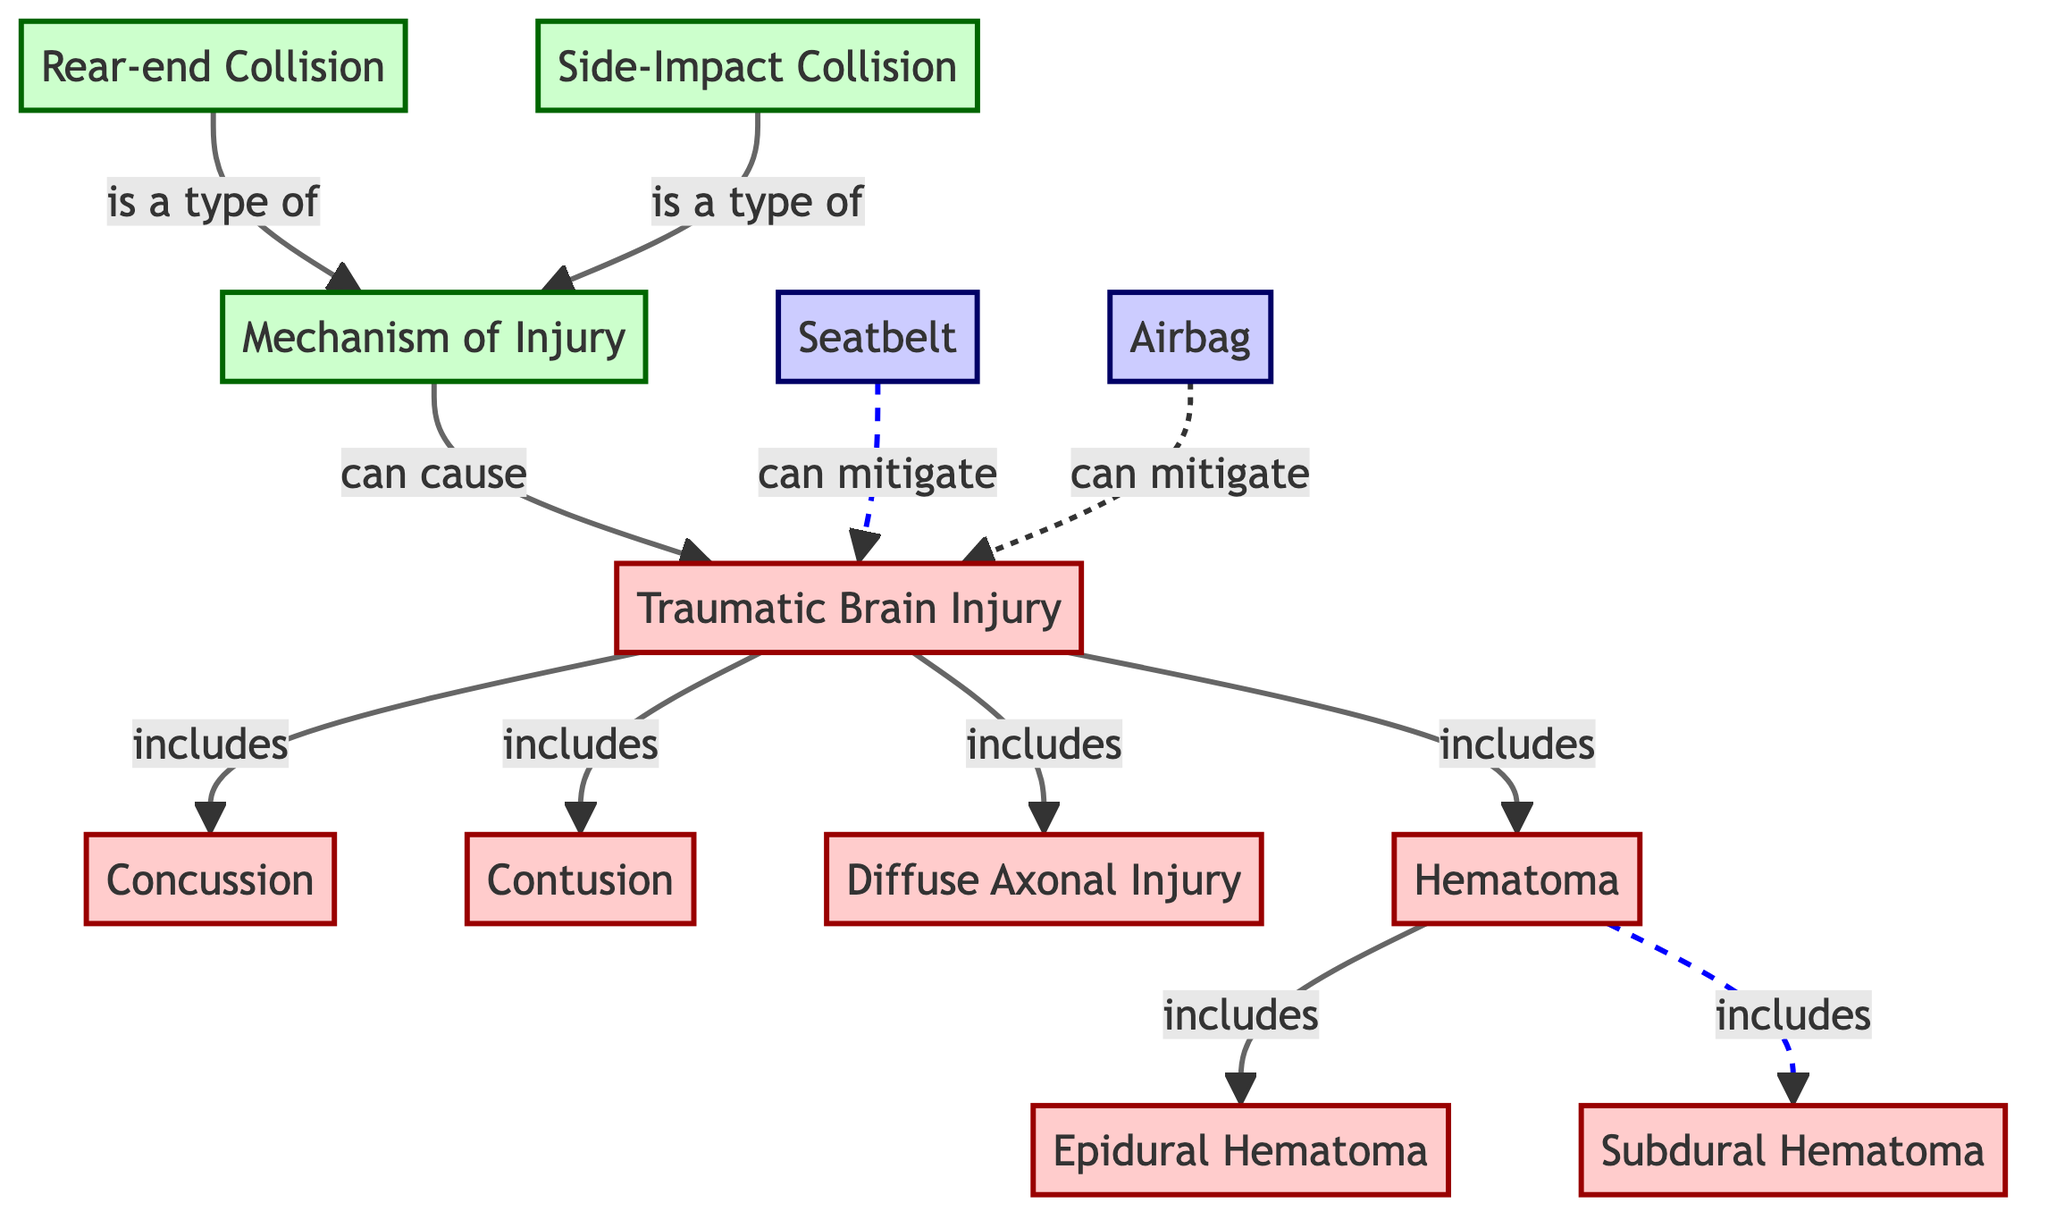What are the types of injuries included under Traumatic Brain Injury? The diagram indicates that Traumatic Brain Injury includes Concussion, Contusion, Diffuse Axonal Injury, and Hematoma. By following the connection from the TBI node, we can identify these injury types listed.
Answer: Concussion, Contusion, Diffuse Axonal Injury, Hematoma How many types of hematoma are specified in the diagram? The diagram shows that there are two types of hematoma: Epidural Hematoma and Subdural Hematoma. By tracing the connection from the Hematoma node, we see it branches into these two types.
Answer: 2 What mechanism of injury is associated with a side-impact collision? According to the diagram, a side-impact collision is a type of Mechanism of Injury (MOI), which can cause Traumatic Brain Injury. Thus, it is directly linked to the MOI node as a specific type.
Answer: Side-Impact Collision What mitigation measures are indicated to reduce TBI? The diagram identifies two mitigation measures: Seatbelt and Airbag. These are denoted as dashed connections leading to the TBI node, suggesting their role in reducing the risk of Traumatic Brain Injury.
Answer: Seatbelt, Airbag What type of injury results from Diffuse Axonal Injury? The diagram explicitly states that Diffuse Axonal Injury is a type of Traumatic Brain Injury. To find this, we follow the connection from the DAI node back to the TBI node.
Answer: Traumatic Brain Injury 